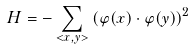<formula> <loc_0><loc_0><loc_500><loc_500>H = - \sum _ { < x , y > } \left ( \varphi ( x ) \cdot \varphi ( y ) \right ) ^ { 2 }</formula> 